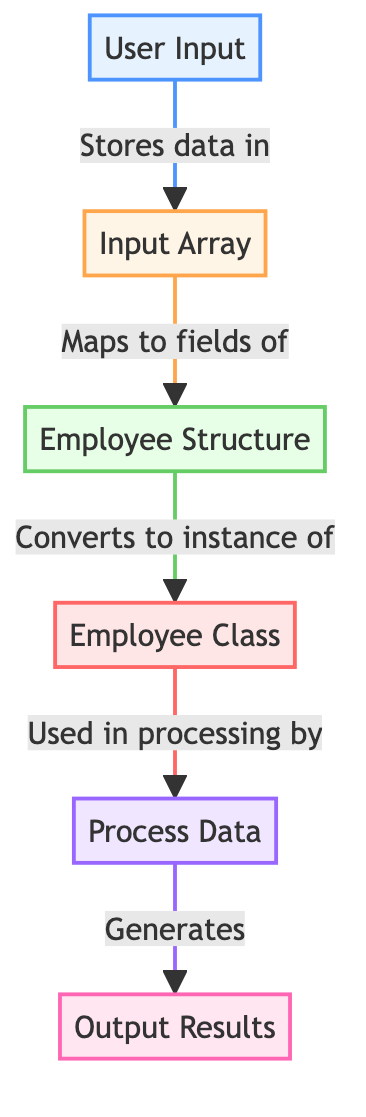What node does the User Input connect to? The User Input node has a directed edge that connects it to the Input Array node, indicating that data from User Input is stored in Input Array.
Answer: Input Array What type of data structure is Employee Structure? The Employee Structure node is labeled as a "Structure", which is explicitly defined in the diagram.
Answer: Structure How many nodes are present in this diagram? By counting all the nodes listed in the diagram, there are a total of six distinct nodes: User Input, Input Array, Employee Structure, Employee Class, Process Data, and Output Results.
Answer: 6 What is the relationship between Input Array and Employee Structure? The directed edge from Input Array to Employee Structure states that Input Array "Maps to fields of" Employee Structure, indicating a mapping relationship.
Answer: Maps to fields of Which node generates Output Results? The Process Data node has a directed edge pointing to the Output Results node, indicating that it is the entity responsible for generating the outputs.
Answer: Process Data What type of data structure is used in the process by the Employee Class? The Employee Class is used in processing by the Process Data node, and since Employee Class is labeled as a "Class", it is the type of data structure involved in processing.
Answer: Class How does data flow from User Input to Output Results? The data flow starts at User Input, which stores data in the Input Array, then maps that array to fields of Employee Structure, which converts it to an instance of Employee Class. Employee Class is then used in processing by Process Data, which finally generates Output Results.
Answer: User Input → Input Array → Employee Structure → Employee Class → Process Data → Output Results In total, how many directed edges are there in the diagram? By counting the connections (directed edges) listed in the diagram, there are five directed edges showcasing the flow of data between the nodes.
Answer: 5 What does the edge from Employee Struct to Employee Class state? The edge states that Employee Struct "Converts to instance of" Employee Class, meaning that data is transformed from one type to another in this step.
Answer: Converts to instance of 